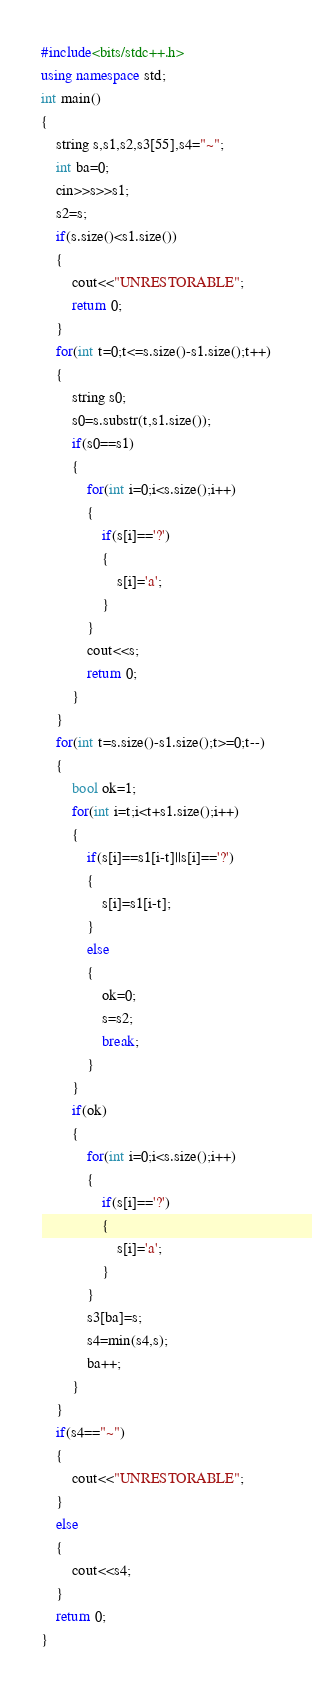<code> <loc_0><loc_0><loc_500><loc_500><_C++_>#include<bits/stdc++.h>
using namespace std;
int main()
{
	string s,s1,s2,s3[55],s4="~";
	int ba=0;
	cin>>s>>s1;
	s2=s;
	if(s.size()<s1.size())
	{
		cout<<"UNRESTORABLE";
		return 0;
	}
	for(int t=0;t<=s.size()-s1.size();t++)
	{
		string s0;
		s0=s.substr(t,s1.size());
		if(s0==s1)
		{
			for(int i=0;i<s.size();i++)
			{
				if(s[i]=='?')
				{
					s[i]='a';
				}
			}
			cout<<s;
			return 0;
		}
	} 
	for(int t=s.size()-s1.size();t>=0;t--)
    {
    	bool ok=1;
    	for(int i=t;i<t+s1.size();i++)
    	{
    		if(s[i]==s1[i-t]||s[i]=='?')
    		{
    			s[i]=s1[i-t];
			}
			else
			{
				ok=0;
				s=s2;
				break;
			}
		}
		if(ok)
		{
			for(int i=0;i<s.size();i++)
			{
				if(s[i]=='?')
				{
					s[i]='a';
				}
			}
			s3[ba]=s;
			s4=min(s4,s);
			ba++;
		}
	}
	if(s4=="~")
	{
		cout<<"UNRESTORABLE";
	}
	else
	{
		cout<<s4;
	}
	return 0;
}
</code> 